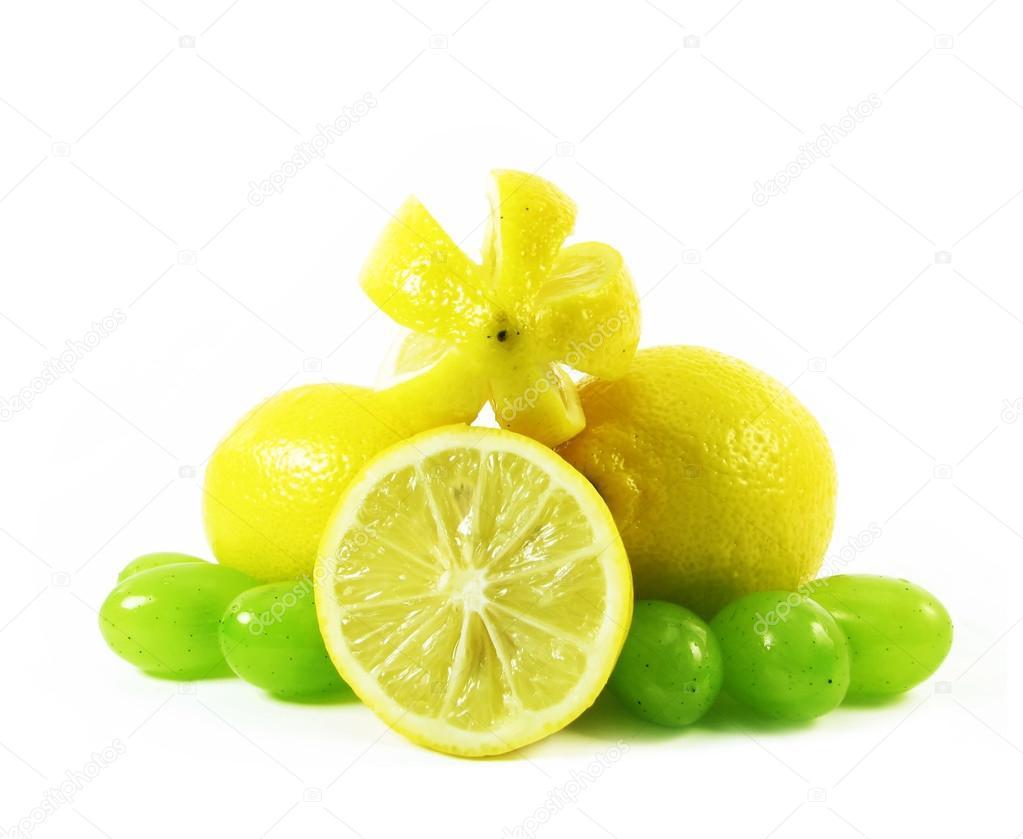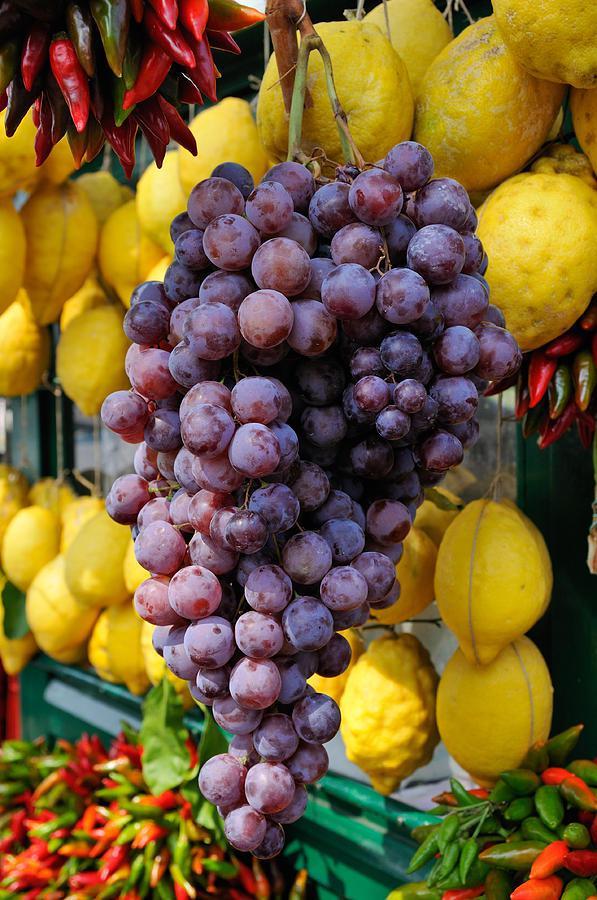The first image is the image on the left, the second image is the image on the right. Given the left and right images, does the statement "At least one image features a bunch of purple grapes on the vine." hold true? Answer yes or no. Yes. 